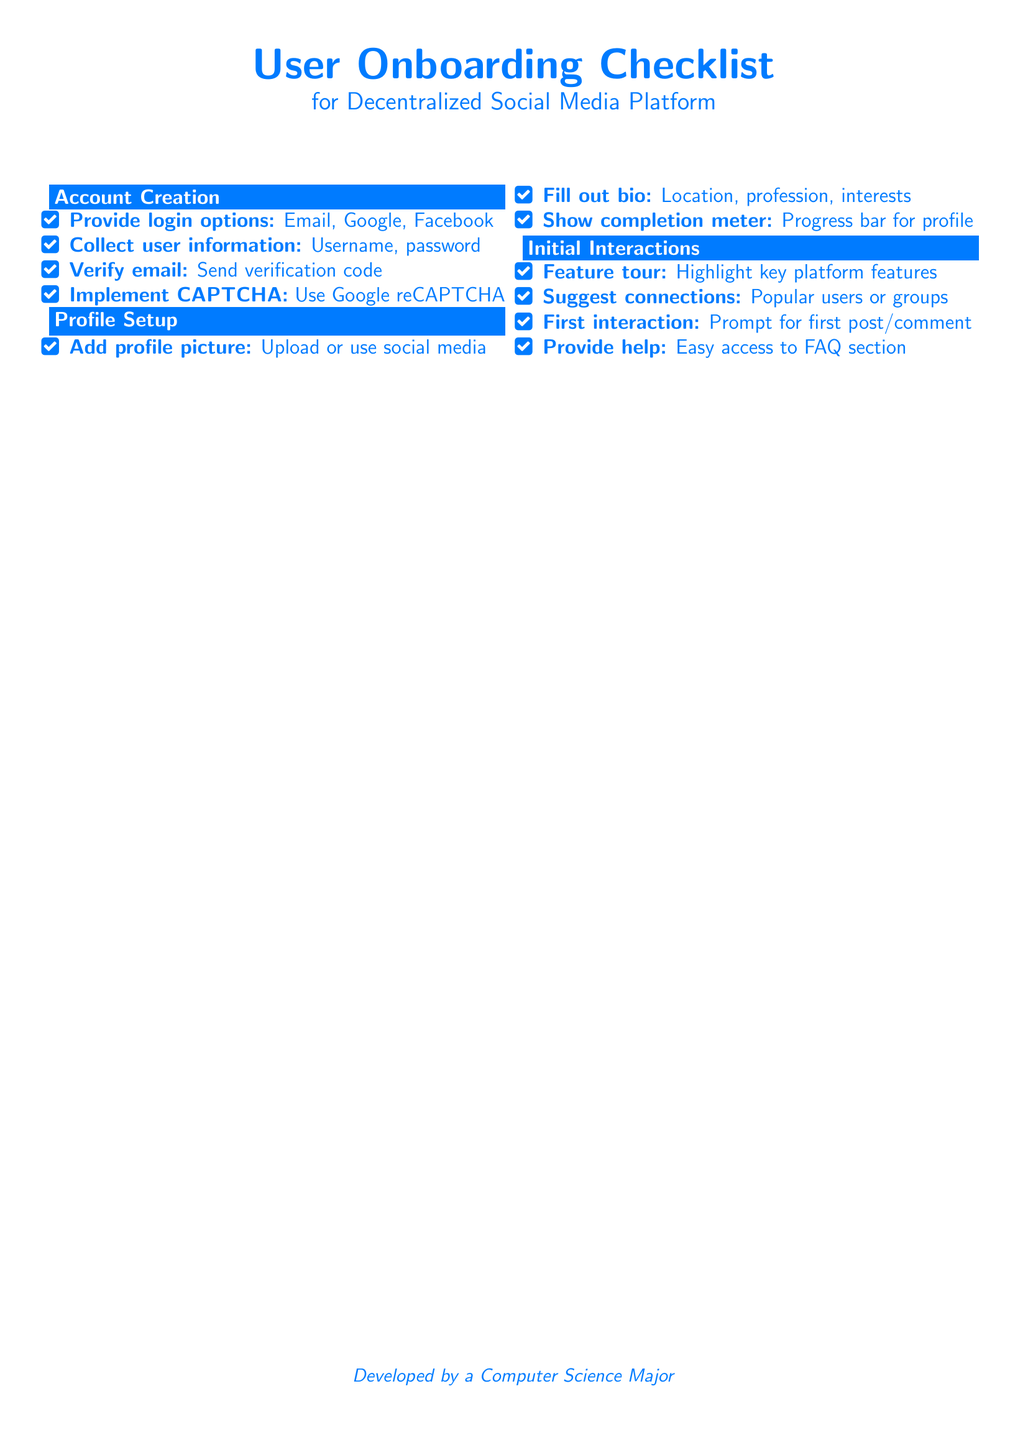What login options are provided? The login options are listed under Account Creation, which include Email, Google, and Facebook.
Answer: Email, Google, Facebook How many steps are there in the Profile Setup section? The Profile Setup section includes three steps detailed in the document.
Answer: 3 What feature is highlighted in the Initial Interactions section? The Initial Interactions section suggests highlighting key platform features as part of the onboarding process.
Answer: Key platform features What does the completion meter show in the Profile Setup? The completion meter shows the progress of the user's profile setup, indicated by a progress bar.
Answer: Progress bar for profile What is implemented for security during account creation? Security during account creation is addressed through the implementation of CAPTCHA.
Answer: CAPTCHA 